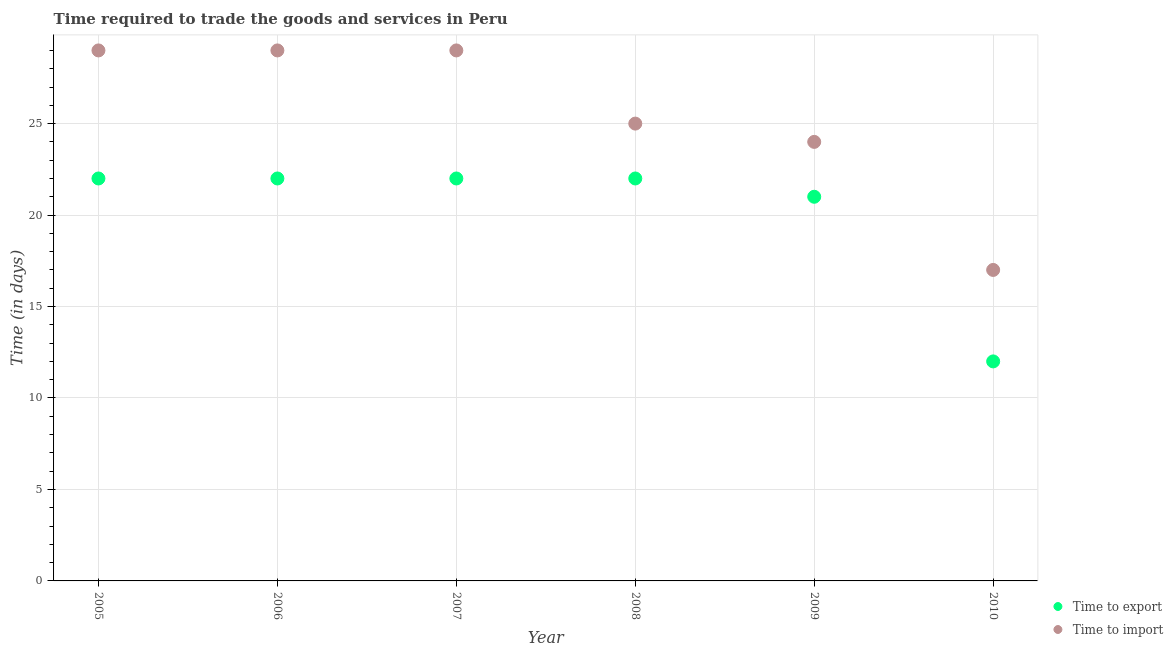Is the number of dotlines equal to the number of legend labels?
Offer a very short reply. Yes. What is the time to import in 2010?
Provide a succinct answer. 17. Across all years, what is the maximum time to import?
Provide a succinct answer. 29. Across all years, what is the minimum time to import?
Offer a terse response. 17. What is the total time to export in the graph?
Ensure brevity in your answer.  121. What is the difference between the time to import in 2006 and that in 2007?
Provide a succinct answer. 0. What is the difference between the time to import in 2005 and the time to export in 2009?
Offer a very short reply. 8. What is the average time to export per year?
Keep it short and to the point. 20.17. In the year 2007, what is the difference between the time to import and time to export?
Provide a short and direct response. 7. In how many years, is the time to export greater than 21 days?
Your response must be concise. 4. What is the ratio of the time to import in 2008 to that in 2010?
Make the answer very short. 1.47. Is the time to import in 2007 less than that in 2009?
Give a very brief answer. No. Is the difference between the time to export in 2005 and 2010 greater than the difference between the time to import in 2005 and 2010?
Give a very brief answer. No. What is the difference between the highest and the lowest time to export?
Your answer should be very brief. 10. In how many years, is the time to export greater than the average time to export taken over all years?
Offer a terse response. 5. Is the time to import strictly greater than the time to export over the years?
Offer a very short reply. Yes. Is the time to import strictly less than the time to export over the years?
Keep it short and to the point. No. How many dotlines are there?
Make the answer very short. 2. What is the difference between two consecutive major ticks on the Y-axis?
Keep it short and to the point. 5. Does the graph contain any zero values?
Make the answer very short. No. Where does the legend appear in the graph?
Provide a short and direct response. Bottom right. How are the legend labels stacked?
Make the answer very short. Vertical. What is the title of the graph?
Ensure brevity in your answer.  Time required to trade the goods and services in Peru. What is the label or title of the X-axis?
Your response must be concise. Year. What is the label or title of the Y-axis?
Make the answer very short. Time (in days). What is the Time (in days) in Time to export in 2005?
Make the answer very short. 22. What is the Time (in days) in Time to export in 2006?
Offer a very short reply. 22. What is the Time (in days) of Time to export in 2007?
Your answer should be very brief. 22. What is the Time (in days) of Time to import in 2007?
Your answer should be compact. 29. What is the Time (in days) in Time to export in 2008?
Your answer should be very brief. 22. What is the Time (in days) in Time to import in 2008?
Offer a very short reply. 25. What is the Time (in days) of Time to export in 2010?
Keep it short and to the point. 12. What is the Time (in days) of Time to import in 2010?
Ensure brevity in your answer.  17. Across all years, what is the minimum Time (in days) of Time to export?
Provide a succinct answer. 12. Across all years, what is the minimum Time (in days) in Time to import?
Ensure brevity in your answer.  17. What is the total Time (in days) in Time to export in the graph?
Your answer should be very brief. 121. What is the total Time (in days) in Time to import in the graph?
Your answer should be very brief. 153. What is the difference between the Time (in days) of Time to import in 2005 and that in 2006?
Offer a very short reply. 0. What is the difference between the Time (in days) of Time to export in 2005 and that in 2009?
Make the answer very short. 1. What is the difference between the Time (in days) in Time to import in 2005 and that in 2009?
Your response must be concise. 5. What is the difference between the Time (in days) of Time to import in 2005 and that in 2010?
Offer a terse response. 12. What is the difference between the Time (in days) in Time to import in 2006 and that in 2008?
Provide a succinct answer. 4. What is the difference between the Time (in days) in Time to export in 2006 and that in 2009?
Ensure brevity in your answer.  1. What is the difference between the Time (in days) in Time to import in 2006 and that in 2009?
Offer a very short reply. 5. What is the difference between the Time (in days) in Time to import in 2006 and that in 2010?
Provide a short and direct response. 12. What is the difference between the Time (in days) of Time to export in 2007 and that in 2008?
Offer a terse response. 0. What is the difference between the Time (in days) of Time to import in 2007 and that in 2008?
Your answer should be very brief. 4. What is the difference between the Time (in days) of Time to export in 2007 and that in 2009?
Offer a terse response. 1. What is the difference between the Time (in days) of Time to import in 2007 and that in 2009?
Keep it short and to the point. 5. What is the difference between the Time (in days) in Time to export in 2008 and that in 2009?
Your response must be concise. 1. What is the difference between the Time (in days) of Time to import in 2008 and that in 2010?
Your answer should be compact. 8. What is the difference between the Time (in days) of Time to export in 2009 and that in 2010?
Your answer should be compact. 9. What is the difference between the Time (in days) in Time to export in 2005 and the Time (in days) in Time to import in 2007?
Your answer should be very brief. -7. What is the difference between the Time (in days) in Time to export in 2005 and the Time (in days) in Time to import in 2008?
Your response must be concise. -3. What is the difference between the Time (in days) of Time to export in 2005 and the Time (in days) of Time to import in 2010?
Ensure brevity in your answer.  5. What is the difference between the Time (in days) of Time to export in 2006 and the Time (in days) of Time to import in 2007?
Provide a short and direct response. -7. What is the difference between the Time (in days) of Time to export in 2006 and the Time (in days) of Time to import in 2010?
Keep it short and to the point. 5. What is the difference between the Time (in days) in Time to export in 2008 and the Time (in days) in Time to import in 2010?
Provide a short and direct response. 5. What is the average Time (in days) in Time to export per year?
Make the answer very short. 20.17. What is the average Time (in days) of Time to import per year?
Provide a succinct answer. 25.5. In the year 2005, what is the difference between the Time (in days) in Time to export and Time (in days) in Time to import?
Keep it short and to the point. -7. In the year 2006, what is the difference between the Time (in days) of Time to export and Time (in days) of Time to import?
Offer a very short reply. -7. In the year 2007, what is the difference between the Time (in days) in Time to export and Time (in days) in Time to import?
Your answer should be very brief. -7. In the year 2008, what is the difference between the Time (in days) in Time to export and Time (in days) in Time to import?
Offer a very short reply. -3. In the year 2009, what is the difference between the Time (in days) in Time to export and Time (in days) in Time to import?
Provide a succinct answer. -3. In the year 2010, what is the difference between the Time (in days) of Time to export and Time (in days) of Time to import?
Make the answer very short. -5. What is the ratio of the Time (in days) of Time to import in 2005 to that in 2006?
Offer a terse response. 1. What is the ratio of the Time (in days) of Time to export in 2005 to that in 2007?
Give a very brief answer. 1. What is the ratio of the Time (in days) in Time to import in 2005 to that in 2008?
Keep it short and to the point. 1.16. What is the ratio of the Time (in days) of Time to export in 2005 to that in 2009?
Offer a terse response. 1.05. What is the ratio of the Time (in days) in Time to import in 2005 to that in 2009?
Your response must be concise. 1.21. What is the ratio of the Time (in days) in Time to export in 2005 to that in 2010?
Ensure brevity in your answer.  1.83. What is the ratio of the Time (in days) of Time to import in 2005 to that in 2010?
Give a very brief answer. 1.71. What is the ratio of the Time (in days) of Time to export in 2006 to that in 2008?
Ensure brevity in your answer.  1. What is the ratio of the Time (in days) of Time to import in 2006 to that in 2008?
Your answer should be very brief. 1.16. What is the ratio of the Time (in days) of Time to export in 2006 to that in 2009?
Your response must be concise. 1.05. What is the ratio of the Time (in days) in Time to import in 2006 to that in 2009?
Keep it short and to the point. 1.21. What is the ratio of the Time (in days) in Time to export in 2006 to that in 2010?
Provide a succinct answer. 1.83. What is the ratio of the Time (in days) in Time to import in 2006 to that in 2010?
Your response must be concise. 1.71. What is the ratio of the Time (in days) of Time to import in 2007 to that in 2008?
Give a very brief answer. 1.16. What is the ratio of the Time (in days) in Time to export in 2007 to that in 2009?
Provide a succinct answer. 1.05. What is the ratio of the Time (in days) of Time to import in 2007 to that in 2009?
Offer a very short reply. 1.21. What is the ratio of the Time (in days) in Time to export in 2007 to that in 2010?
Your answer should be very brief. 1.83. What is the ratio of the Time (in days) of Time to import in 2007 to that in 2010?
Provide a short and direct response. 1.71. What is the ratio of the Time (in days) in Time to export in 2008 to that in 2009?
Your answer should be compact. 1.05. What is the ratio of the Time (in days) of Time to import in 2008 to that in 2009?
Ensure brevity in your answer.  1.04. What is the ratio of the Time (in days) in Time to export in 2008 to that in 2010?
Your answer should be compact. 1.83. What is the ratio of the Time (in days) of Time to import in 2008 to that in 2010?
Give a very brief answer. 1.47. What is the ratio of the Time (in days) of Time to import in 2009 to that in 2010?
Keep it short and to the point. 1.41. What is the difference between the highest and the second highest Time (in days) in Time to export?
Give a very brief answer. 0. What is the difference between the highest and the lowest Time (in days) of Time to export?
Your answer should be compact. 10. What is the difference between the highest and the lowest Time (in days) in Time to import?
Your response must be concise. 12. 